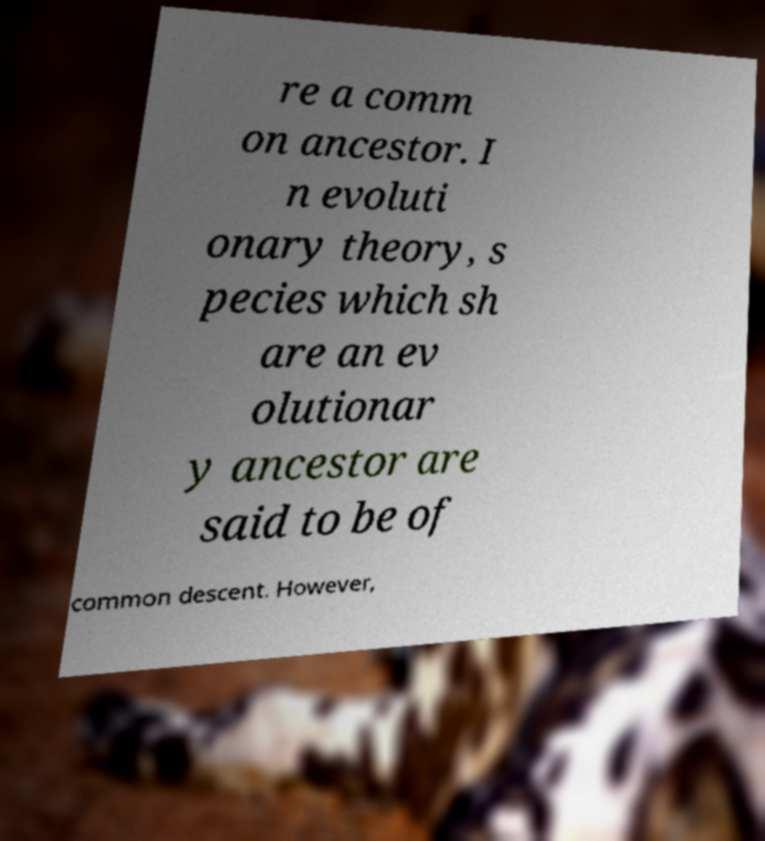Could you assist in decoding the text presented in this image and type it out clearly? re a comm on ancestor. I n evoluti onary theory, s pecies which sh are an ev olutionar y ancestor are said to be of common descent. However, 